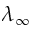<formula> <loc_0><loc_0><loc_500><loc_500>\lambda _ { \infty }</formula> 